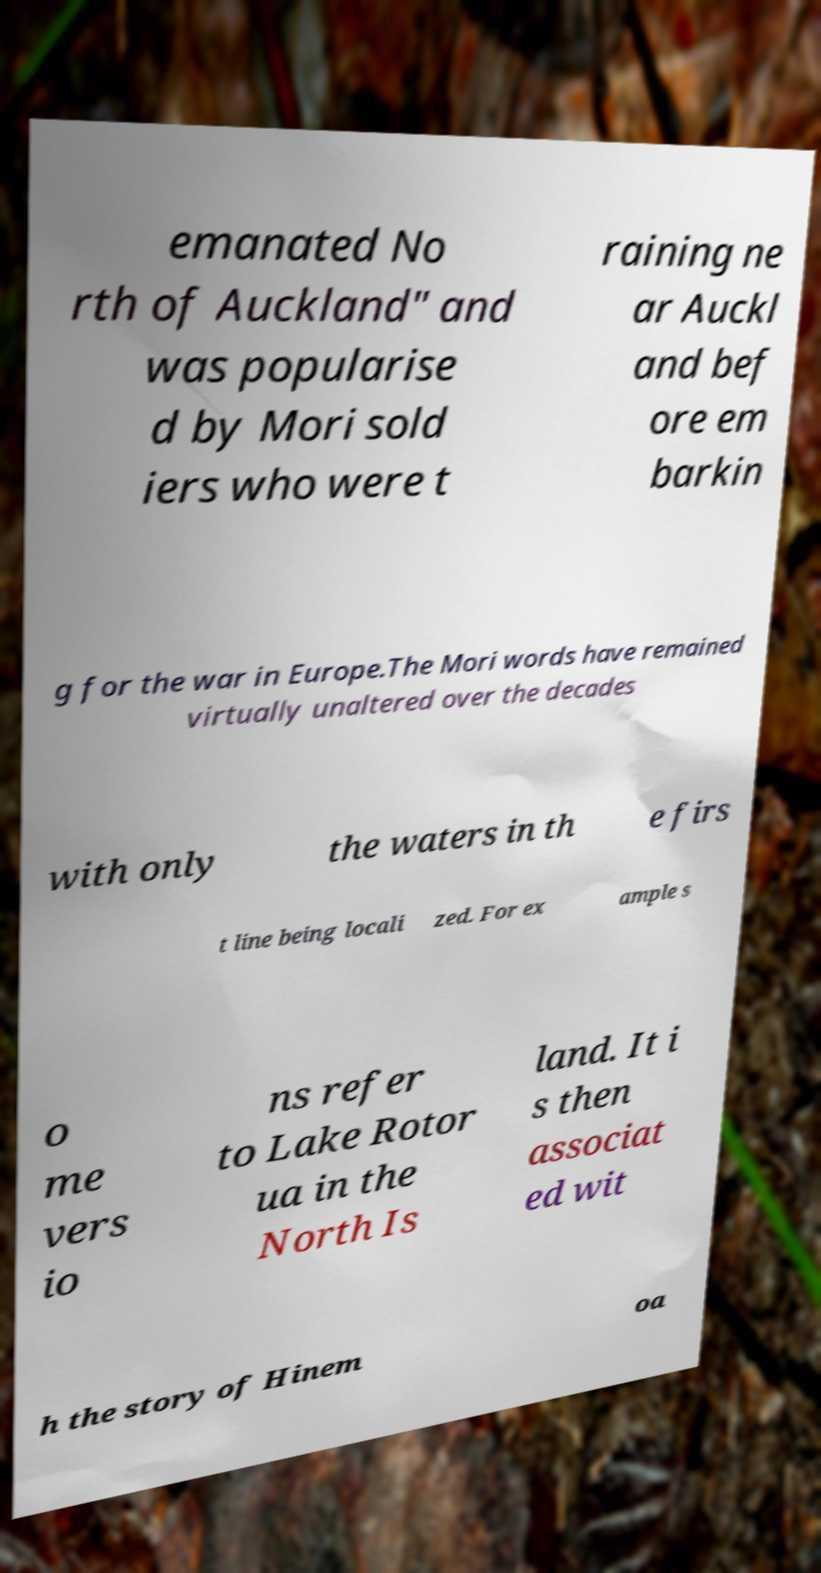Can you accurately transcribe the text from the provided image for me? emanated No rth of Auckland" and was popularise d by Mori sold iers who were t raining ne ar Auckl and bef ore em barkin g for the war in Europe.The Mori words have remained virtually unaltered over the decades with only the waters in th e firs t line being locali zed. For ex ample s o me vers io ns refer to Lake Rotor ua in the North Is land. It i s then associat ed wit h the story of Hinem oa 